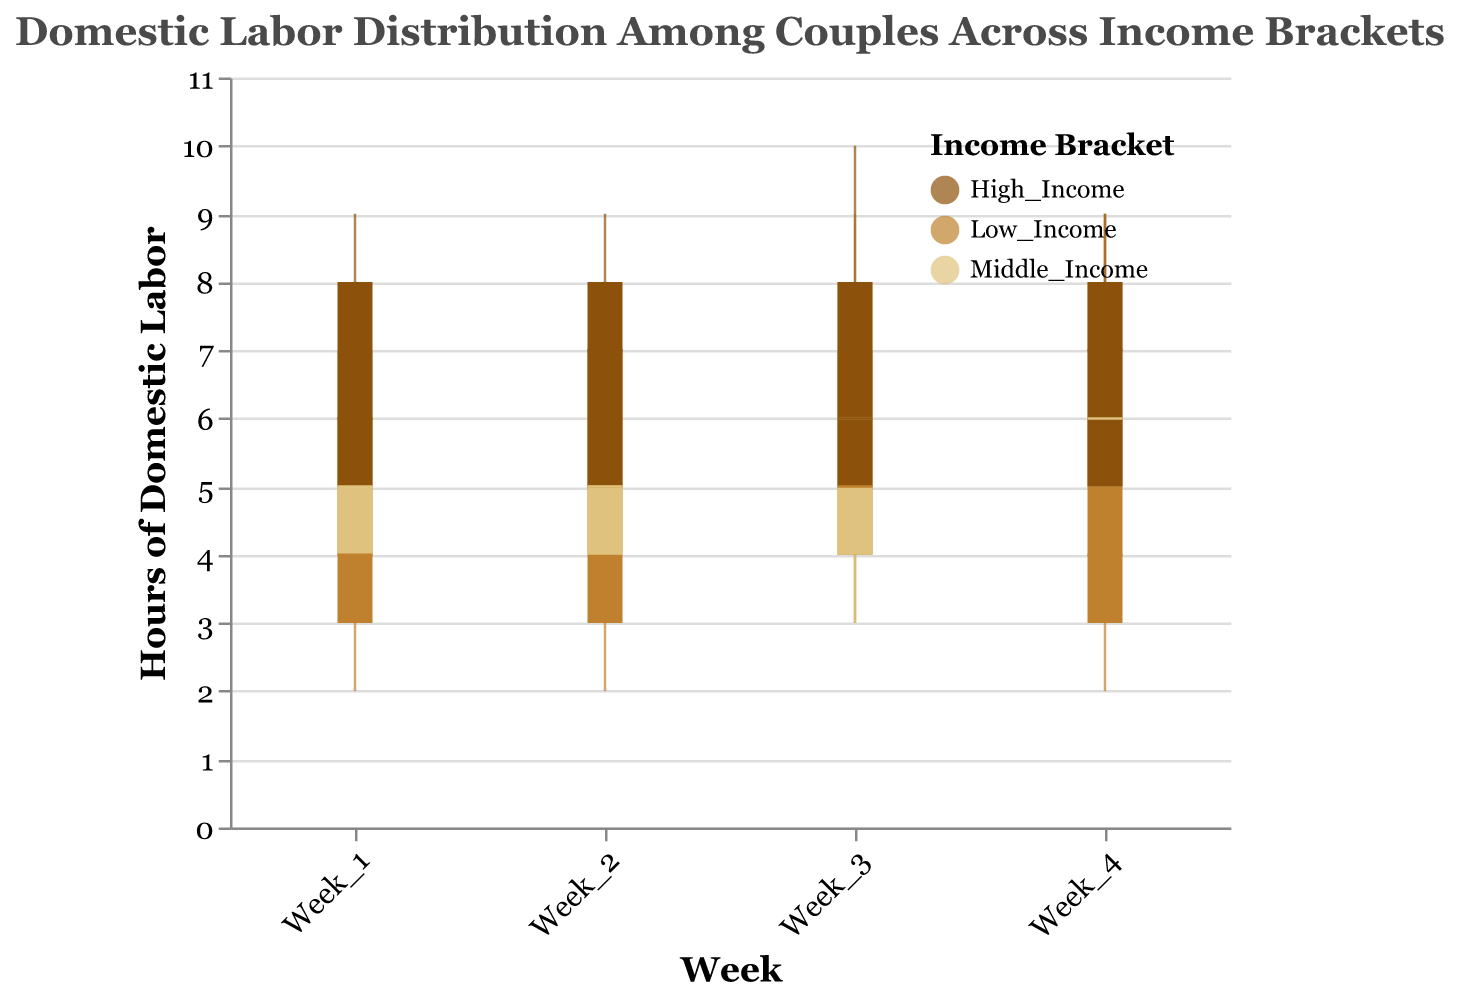What is the range of domestic labor hours for Week 1 in the Low Income bracket? The range of hours is from Min to Max. For Low Income in Week 1, Min is 2 and Max is 7.
Answer: 2 to 7 What is the median domestic labor hours for Week 3 in the High Income bracket? The median value is indicated by a white tick mark. For High Income in Week 3, the median is 6.
Answer: 6 Which Income Bracket has the highest upper quartile value in Week 3? The upper quartile for each bracket is shown by the top end of the bar. In Week 3, High Income has an upper quartile of 8 and Low Income has an upper quartile of 7. Middle Income has an upper quartile of 8, but High Income also reaches the Min value of 4, which is lower. Comparing these, High Income has the highest upper quartile value.
Answer: High Income What is the general trend of median domestic labor hours from Week 1 to Week 4 across all brackets? Check the white ticks representing the median for each Week and bracket. For Low Income: 4, 5, 5, 4; for Middle Income: 5, 5, 6, 6; for High Income: 6, 7, 6, 7. Overall, Low Income shows a mostly stable trend, Middle Income shows a slight increase, and High Income fluctuates but generally increases.
Answer: Low Income: Stable, Middle Income: Slight Increase, High Income: Fluctuates with an overall increasing trend Which Income Bracket experienced the highest increase in median domestic labor hours from Week 1 to Week 4? Compare the median values at Week 1 and Week 4 for each bracket. Low Income: 4 to 4, Middle Income: 5 to 6, High Income: 6 to 7. Middle Income increases by 1 hour, High Income increases by 1 hour, Low Income shows no increase.
Answer: Middle Income and High Income (tie) For Week 4, what is the interquartile range (IQR) for Middle Income and how is it calculated? The IQR is calculated as the difference between Upper Quartile and Lower Quartile. For Middle Income in Week 4, Upper Quartile is 8 and Lower Quartile is 5. So, IQR = 8 - 5.
Answer: 3 